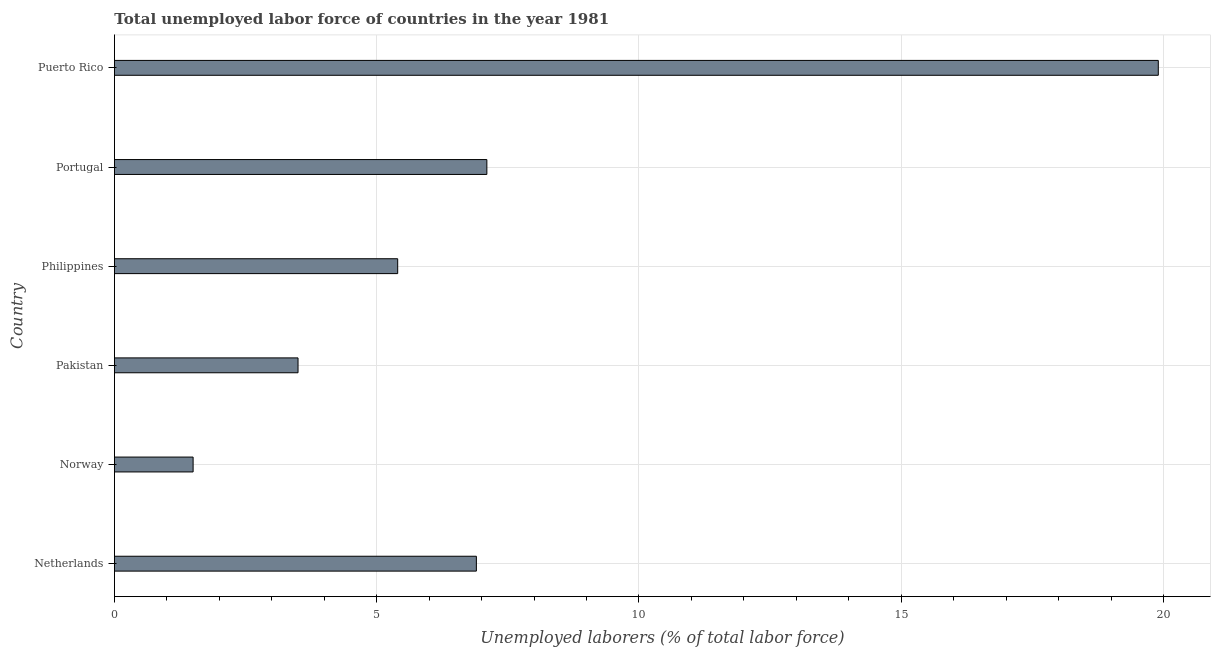Does the graph contain any zero values?
Offer a very short reply. No. What is the title of the graph?
Offer a terse response. Total unemployed labor force of countries in the year 1981. What is the label or title of the X-axis?
Give a very brief answer. Unemployed laborers (% of total labor force). What is the label or title of the Y-axis?
Provide a short and direct response. Country. What is the total unemployed labour force in Puerto Rico?
Make the answer very short. 19.9. Across all countries, what is the maximum total unemployed labour force?
Your response must be concise. 19.9. Across all countries, what is the minimum total unemployed labour force?
Your answer should be compact. 1.5. In which country was the total unemployed labour force maximum?
Offer a terse response. Puerto Rico. In which country was the total unemployed labour force minimum?
Make the answer very short. Norway. What is the sum of the total unemployed labour force?
Ensure brevity in your answer.  44.3. What is the difference between the total unemployed labour force in Pakistan and Puerto Rico?
Offer a very short reply. -16.4. What is the average total unemployed labour force per country?
Offer a very short reply. 7.38. What is the median total unemployed labour force?
Provide a succinct answer. 6.15. What is the ratio of the total unemployed labour force in Norway to that in Pakistan?
Offer a very short reply. 0.43. Is the difference between the total unemployed labour force in Philippines and Portugal greater than the difference between any two countries?
Your response must be concise. No. What is the difference between the highest and the lowest total unemployed labour force?
Ensure brevity in your answer.  18.4. Are all the bars in the graph horizontal?
Give a very brief answer. Yes. How many countries are there in the graph?
Give a very brief answer. 6. What is the Unemployed laborers (% of total labor force) of Netherlands?
Provide a succinct answer. 6.9. What is the Unemployed laborers (% of total labor force) in Pakistan?
Ensure brevity in your answer.  3.5. What is the Unemployed laborers (% of total labor force) in Philippines?
Provide a short and direct response. 5.4. What is the Unemployed laborers (% of total labor force) in Portugal?
Give a very brief answer. 7.1. What is the Unemployed laborers (% of total labor force) in Puerto Rico?
Your answer should be compact. 19.9. What is the difference between the Unemployed laborers (% of total labor force) in Norway and Philippines?
Offer a terse response. -3.9. What is the difference between the Unemployed laborers (% of total labor force) in Norway and Portugal?
Ensure brevity in your answer.  -5.6. What is the difference between the Unemployed laborers (% of total labor force) in Norway and Puerto Rico?
Your answer should be very brief. -18.4. What is the difference between the Unemployed laborers (% of total labor force) in Pakistan and Portugal?
Offer a very short reply. -3.6. What is the difference between the Unemployed laborers (% of total labor force) in Pakistan and Puerto Rico?
Offer a very short reply. -16.4. What is the difference between the Unemployed laborers (% of total labor force) in Philippines and Portugal?
Offer a terse response. -1.7. What is the difference between the Unemployed laborers (% of total labor force) in Philippines and Puerto Rico?
Ensure brevity in your answer.  -14.5. What is the ratio of the Unemployed laborers (% of total labor force) in Netherlands to that in Pakistan?
Your answer should be very brief. 1.97. What is the ratio of the Unemployed laborers (% of total labor force) in Netherlands to that in Philippines?
Provide a succinct answer. 1.28. What is the ratio of the Unemployed laborers (% of total labor force) in Netherlands to that in Portugal?
Provide a short and direct response. 0.97. What is the ratio of the Unemployed laborers (% of total labor force) in Netherlands to that in Puerto Rico?
Give a very brief answer. 0.35. What is the ratio of the Unemployed laborers (% of total labor force) in Norway to that in Pakistan?
Keep it short and to the point. 0.43. What is the ratio of the Unemployed laborers (% of total labor force) in Norway to that in Philippines?
Make the answer very short. 0.28. What is the ratio of the Unemployed laborers (% of total labor force) in Norway to that in Portugal?
Your answer should be very brief. 0.21. What is the ratio of the Unemployed laborers (% of total labor force) in Norway to that in Puerto Rico?
Provide a short and direct response. 0.07. What is the ratio of the Unemployed laborers (% of total labor force) in Pakistan to that in Philippines?
Offer a terse response. 0.65. What is the ratio of the Unemployed laborers (% of total labor force) in Pakistan to that in Portugal?
Provide a short and direct response. 0.49. What is the ratio of the Unemployed laborers (% of total labor force) in Pakistan to that in Puerto Rico?
Give a very brief answer. 0.18. What is the ratio of the Unemployed laborers (% of total labor force) in Philippines to that in Portugal?
Provide a succinct answer. 0.76. What is the ratio of the Unemployed laborers (% of total labor force) in Philippines to that in Puerto Rico?
Keep it short and to the point. 0.27. What is the ratio of the Unemployed laborers (% of total labor force) in Portugal to that in Puerto Rico?
Provide a succinct answer. 0.36. 